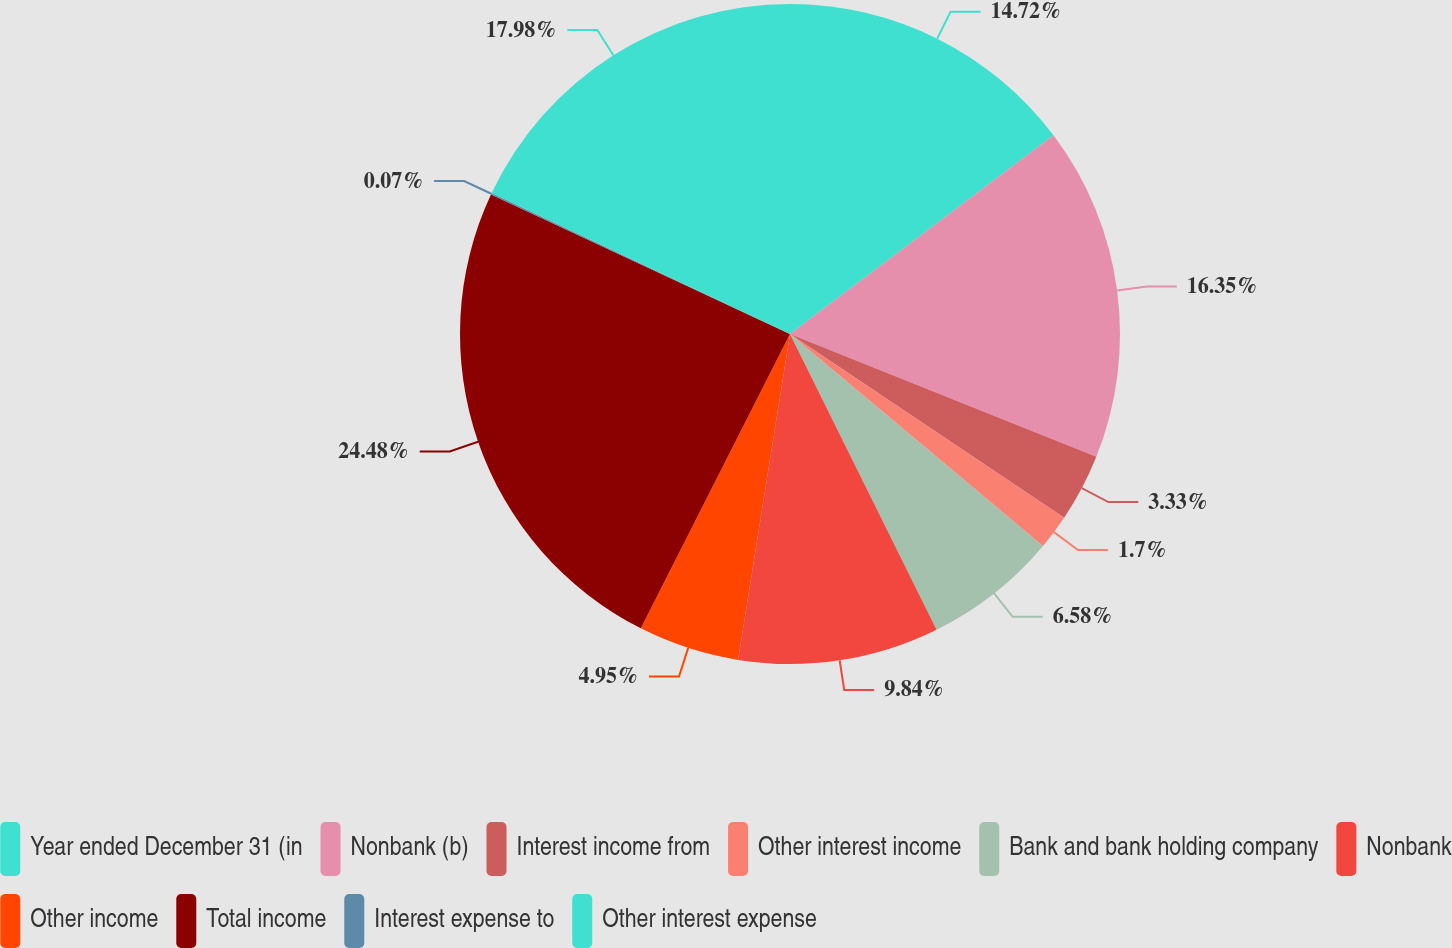<chart> <loc_0><loc_0><loc_500><loc_500><pie_chart><fcel>Year ended December 31 (in<fcel>Nonbank (b)<fcel>Interest income from<fcel>Other interest income<fcel>Bank and bank holding company<fcel>Nonbank<fcel>Other income<fcel>Total income<fcel>Interest expense to<fcel>Other interest expense<nl><fcel>14.72%<fcel>16.35%<fcel>3.33%<fcel>1.7%<fcel>6.58%<fcel>9.84%<fcel>4.95%<fcel>24.49%<fcel>0.07%<fcel>17.98%<nl></chart> 